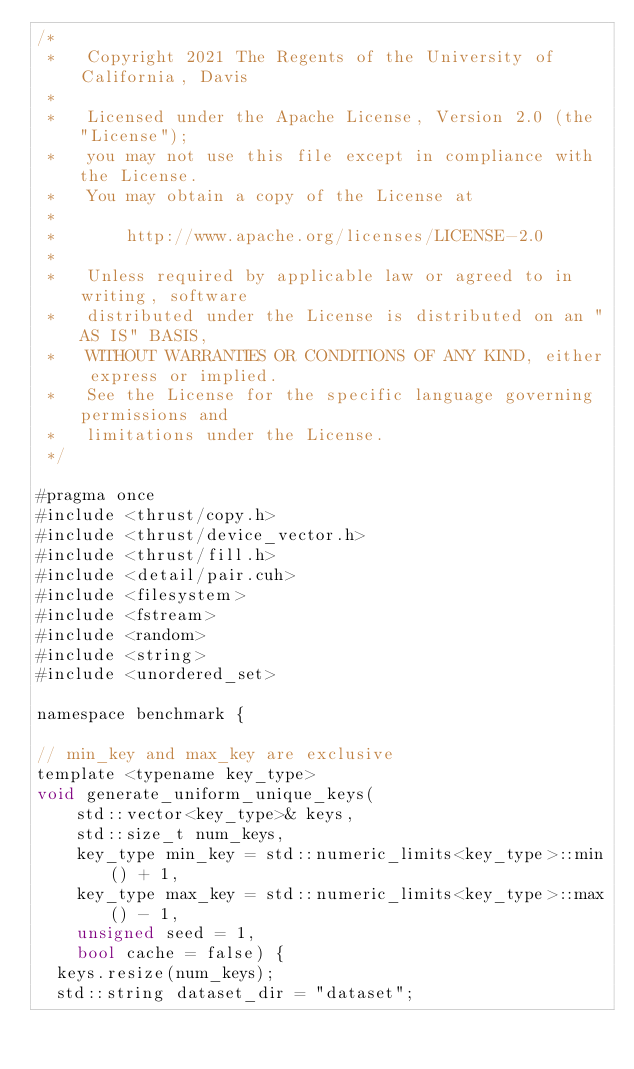<code> <loc_0><loc_0><loc_500><loc_500><_Cuda_>/*
 *   Copyright 2021 The Regents of the University of California, Davis
 *
 *   Licensed under the Apache License, Version 2.0 (the "License");
 *   you may not use this file except in compliance with the License.
 *   You may obtain a copy of the License at
 *
 *       http://www.apache.org/licenses/LICENSE-2.0
 *
 *   Unless required by applicable law or agreed to in writing, software
 *   distributed under the License is distributed on an "AS IS" BASIS,
 *   WITHOUT WARRANTIES OR CONDITIONS OF ANY KIND, either express or implied.
 *   See the License for the specific language governing permissions and
 *   limitations under the License.
 */

#pragma once
#include <thrust/copy.h>
#include <thrust/device_vector.h>
#include <thrust/fill.h>
#include <detail/pair.cuh>
#include <filesystem>
#include <fstream>
#include <random>
#include <string>
#include <unordered_set>

namespace benchmark {

// min_key and max_key are exclusive
template <typename key_type>
void generate_uniform_unique_keys(
    std::vector<key_type>& keys,
    std::size_t num_keys,
    key_type min_key = std::numeric_limits<key_type>::min() + 1,
    key_type max_key = std::numeric_limits<key_type>::max() - 1,
    unsigned seed = 1,
    bool cache = false) {
  keys.resize(num_keys);
  std::string dataset_dir = "dataset";</code> 